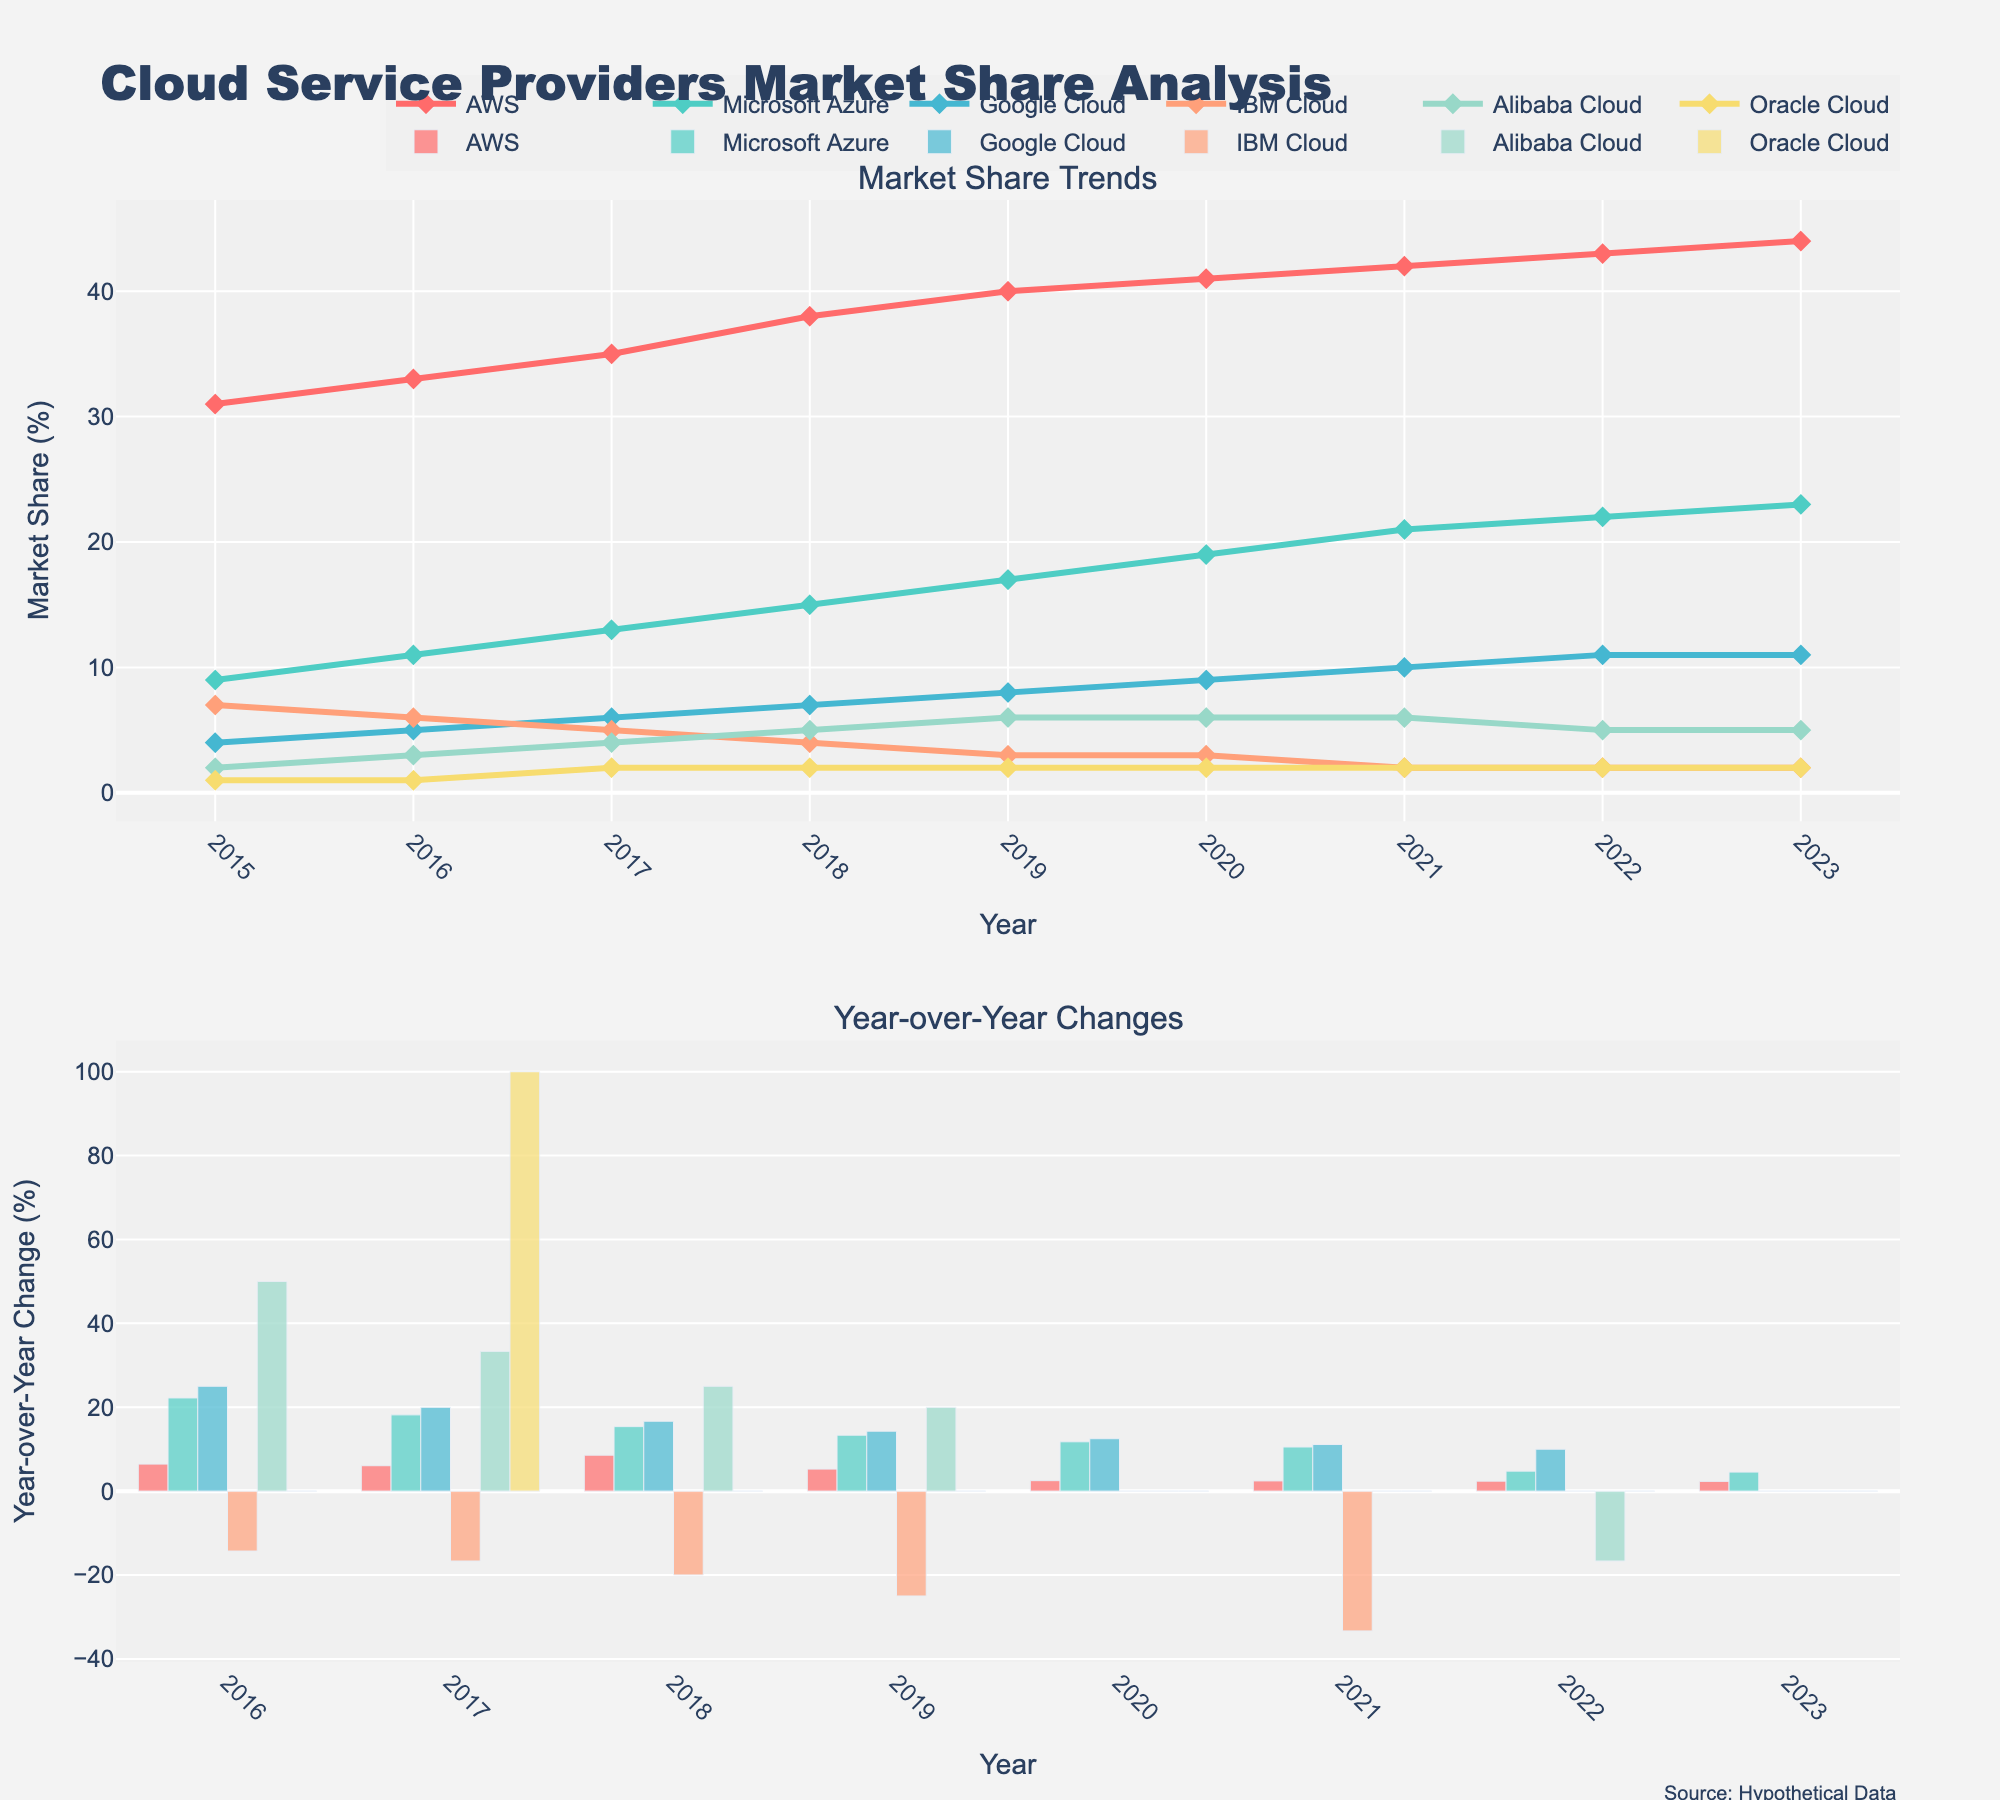What is the main title of the figure? The main title is clearly indicated at the top of the figure. It summarizes the subject of the graphical representation.
Answer: Cloud Service Providers Market Share Analysis Which cloud provider had the highest market share in 2023? Look at the plot for the year 2023 in the "Market Share Trends" subplot. The highest line on the y-axis represents the provider with the highest market share.
Answer: AWS Between which years did Microsoft Azure's market share grow the most? Check the "Market Share Trends" subplot. Follow the line representing Microsoft Azure and compare the differences in percentage market share year over year to find the largest increase.
Answer: 2017 to 2018 What was Google Cloud's market share in 2017? Identify the line for Google Cloud in the "Market Share Trends" and locate the data point aligned with the year 2017.
Answer: 6% How did the market share for IBM Cloud change from 2015 to 2023? Observe the trend line for IBM Cloud in the "Market Share Trends" subplot from the start year 2015 to the end year 2023 to note the overall change.
Answer: It decreased from 7% to 2% Which cloud provider had the highest year-over-year change in 2016? Look at the "Year-over-Year Changes" subplot, focusing on the bars representing 2016. Identify the highest bar.
Answer: Microsoft Azure In which year did Alibaba Cloud experience its highest year-over-year growth rate? In the "Year-over-Year Changes" subplot, examine Alibaba Cloud's bars and find the year with the highest bar.
Answer: 2017 Compare the total market shares of AWS and Google Cloud in 2019. Look at their lines in the "Market Share Trends" subplot for the year 2019. Sum the individual market shares for that year.
Answer: 48% (40% for AWS + 8% for Google Cloud) Which provider showed no change in market share from 2022 to 2023? In the "Market Share Trends" subplot, observe the lines that remain flat between 2022 and 2023.
Answer: Google Cloud, IBM Cloud, Oracle Cloud What was the average year-over-year change for Oracle Cloud from 2015 to 2023? Determine the yearly percentages for Oracle Cloud from the "Year-over-Year Changes" subplot and then calculate the average of these values. Add the values and divide by the number of years.
Answer: Approx. 11.1% 